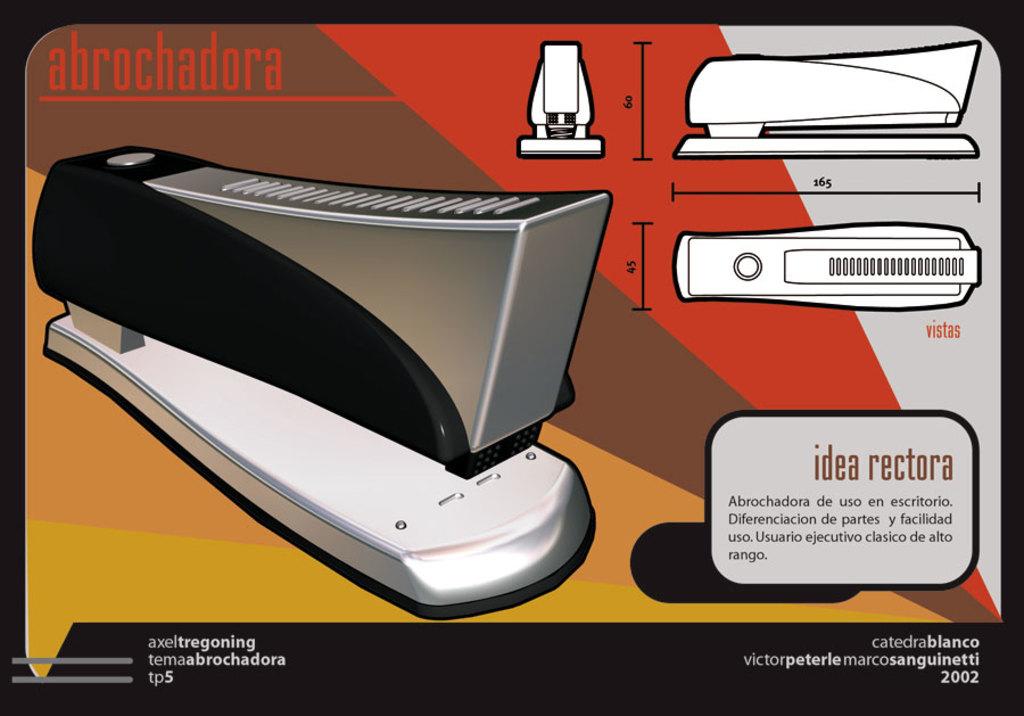What's the year printed on this?
Provide a succinct answer. 2002. 